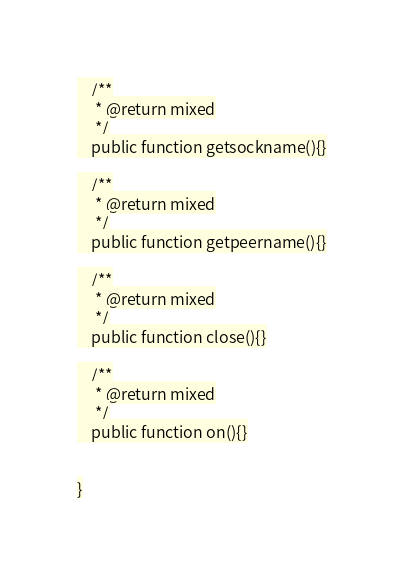Convert code to text. <code><loc_0><loc_0><loc_500><loc_500><_PHP_>    /**
     * @return mixed
     */
    public function getsockname(){}

    /**
     * @return mixed
     */
    public function getpeername(){}

    /**
     * @return mixed
     */
    public function close(){}

    /**
     * @return mixed
     */
    public function on(){}


}
</code> 